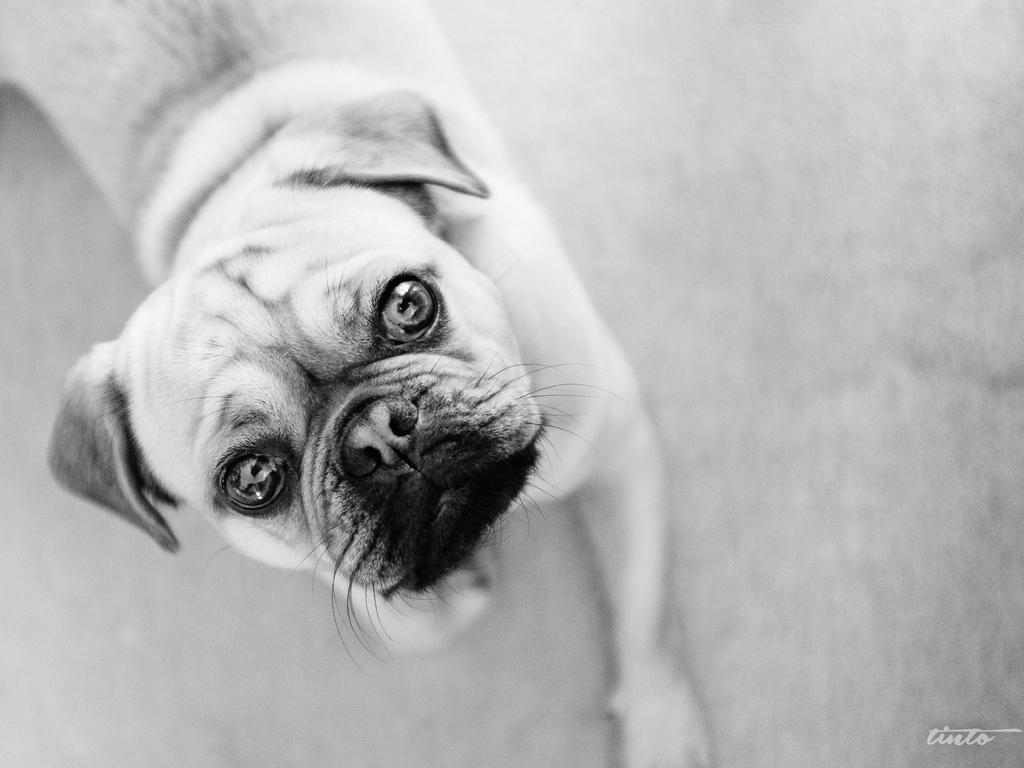What type of creature is in the image? There is an animal in the image. What is the animal standing or sitting on? The animal is on the surface of something. What color scheme is used in the image? The image is black and white. Is the goose flying through the rain in the image? There is no goose or rain present in the image; it features a black and white animal on a surface. 